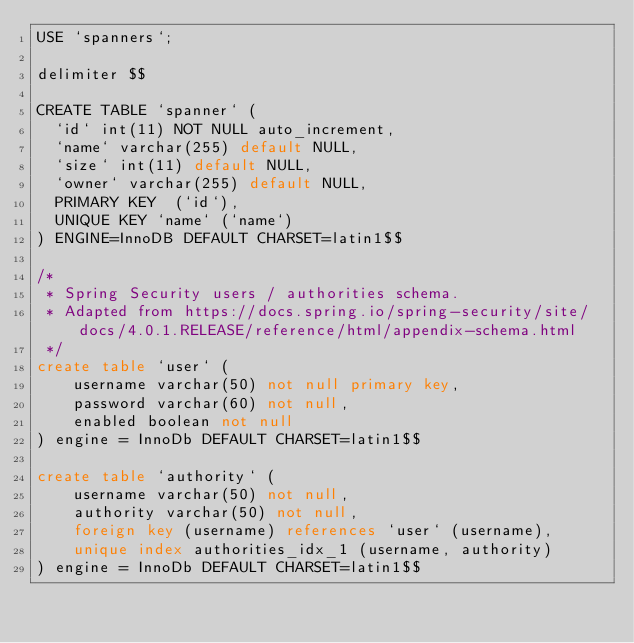<code> <loc_0><loc_0><loc_500><loc_500><_SQL_>USE `spanners`;

delimiter $$

CREATE TABLE `spanner` (
  `id` int(11) NOT NULL auto_increment,
  `name` varchar(255) default NULL,
  `size` int(11) default NULL,
  `owner` varchar(255) default NULL,
  PRIMARY KEY  (`id`),
  UNIQUE KEY `name` (`name`)
) ENGINE=InnoDB DEFAULT CHARSET=latin1$$

/*
 * Spring Security users / authorities schema.
 * Adapted from https://docs.spring.io/spring-security/site/docs/4.0.1.RELEASE/reference/html/appendix-schema.html
 */
create table `user` (
    username varchar(50) not null primary key,
    password varchar(60) not null,
    enabled boolean not null
) engine = InnoDb DEFAULT CHARSET=latin1$$

create table `authority` (
    username varchar(50) not null,
    authority varchar(50) not null,
    foreign key (username) references `user` (username),
    unique index authorities_idx_1 (username, authority)
) engine = InnoDb DEFAULT CHARSET=latin1$$
</code> 